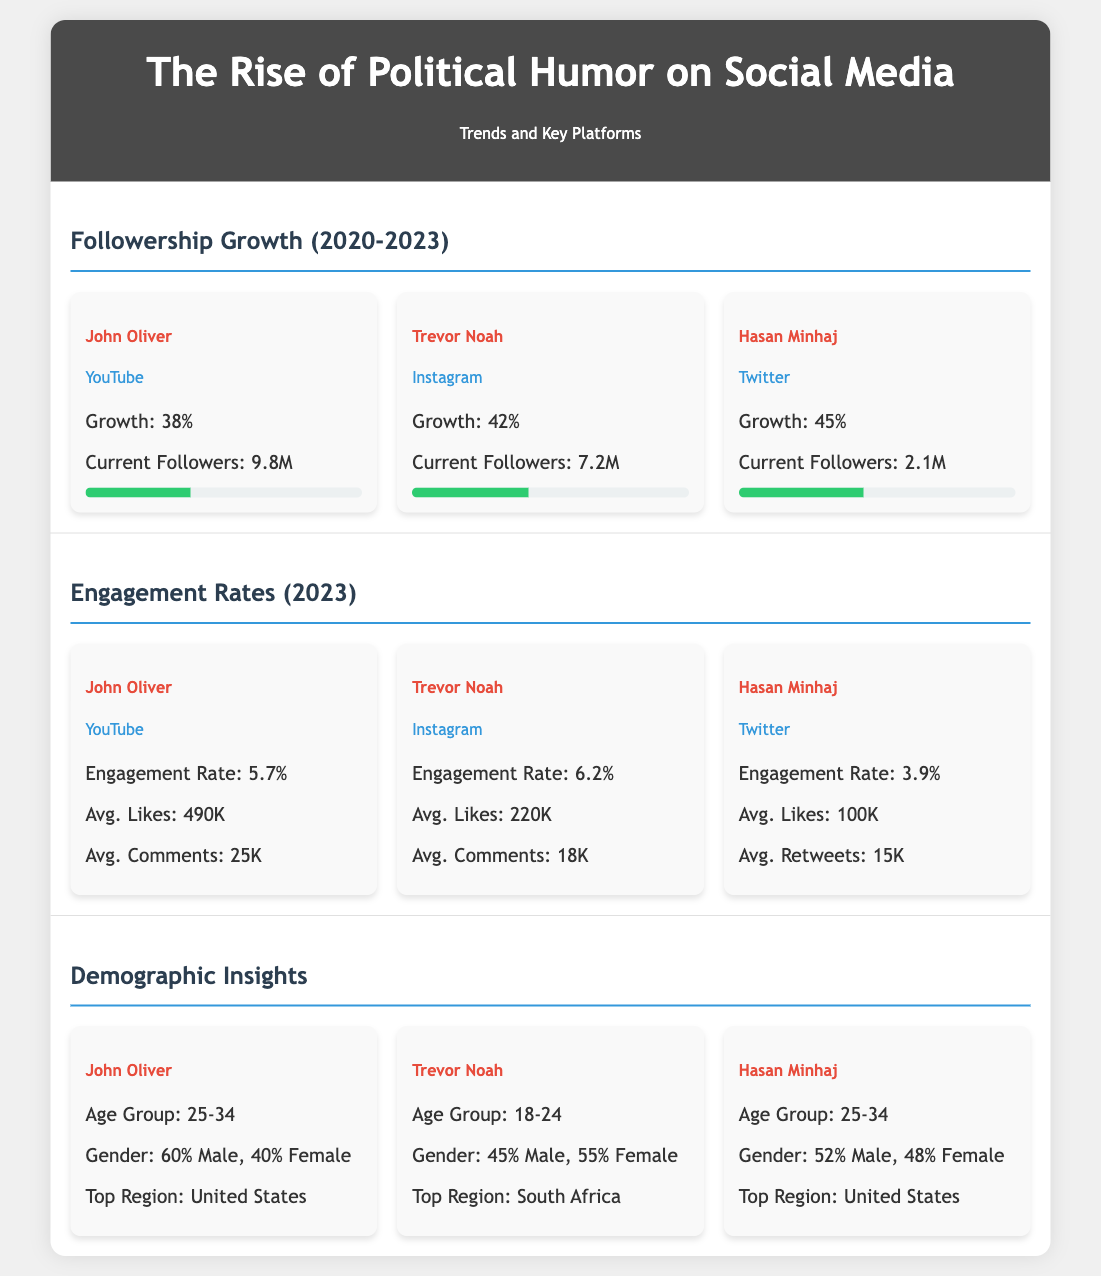What is the growth percentage for John Oliver on YouTube? The growth percentage for John Oliver on YouTube is listed under the followership growth section of the document.
Answer: 38% What platform does Trevor Noah primarily use? The platform for Trevor Noah is specified under the comedian's section in the followership growth part of the infographic.
Answer: Instagram What is Hasan Minhaj's average likes on Twitter? The average likes for Hasan Minhaj on Twitter can be found in the engagement rates section of the document.
Answer: 100K Which comedian has the highest engagement rate? This requires comparing the engagement rates provided for each comedian in the engagement rates section.
Answer: Trevor Noah What age group does John Oliver's audience primarily fall under? The age group for John Oliver is stated in the demographic insights section of the document.
Answer: 25-34 What is the total percentage of females in Trevor Noah's audience? This percentage is provided in the demographic insights section, summarizing the gender breakdown.
Answer: 55% What was the engagement rate for Hasan Minhaj? The engagement rate for Hasan Minhaj is stated in the engagement rates section.
Answer: 3.9% Which region is identified as the top for Hasan Minhaj? The top region for Hasan Minhaj is mentioned in the demographic insights section of the infographic.
Answer: United States 